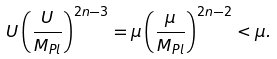Convert formula to latex. <formula><loc_0><loc_0><loc_500><loc_500>U \left ( \frac { U } { M _ { P l } } \right ) ^ { 2 n - 3 } = \mu \left ( \frac { \mu } { M _ { P l } } \right ) ^ { 2 n - 2 } < \mu .</formula> 